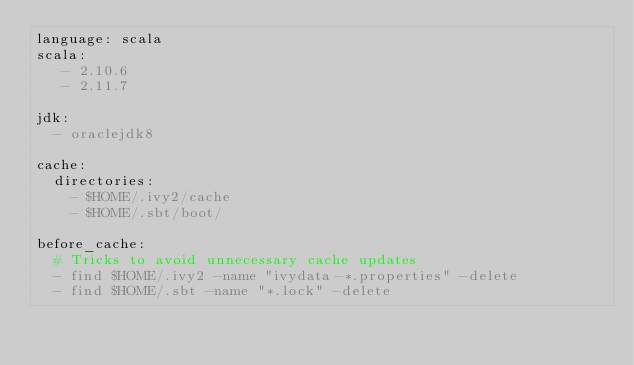<code> <loc_0><loc_0><loc_500><loc_500><_YAML_>language: scala
scala:
   - 2.10.6
   - 2.11.7

jdk:
  - oraclejdk8

cache:
  directories:
    - $HOME/.ivy2/cache
    - $HOME/.sbt/boot/

before_cache:
  # Tricks to avoid unnecessary cache updates
  - find $HOME/.ivy2 -name "ivydata-*.properties" -delete
  - find $HOME/.sbt -name "*.lock" -delete
</code> 